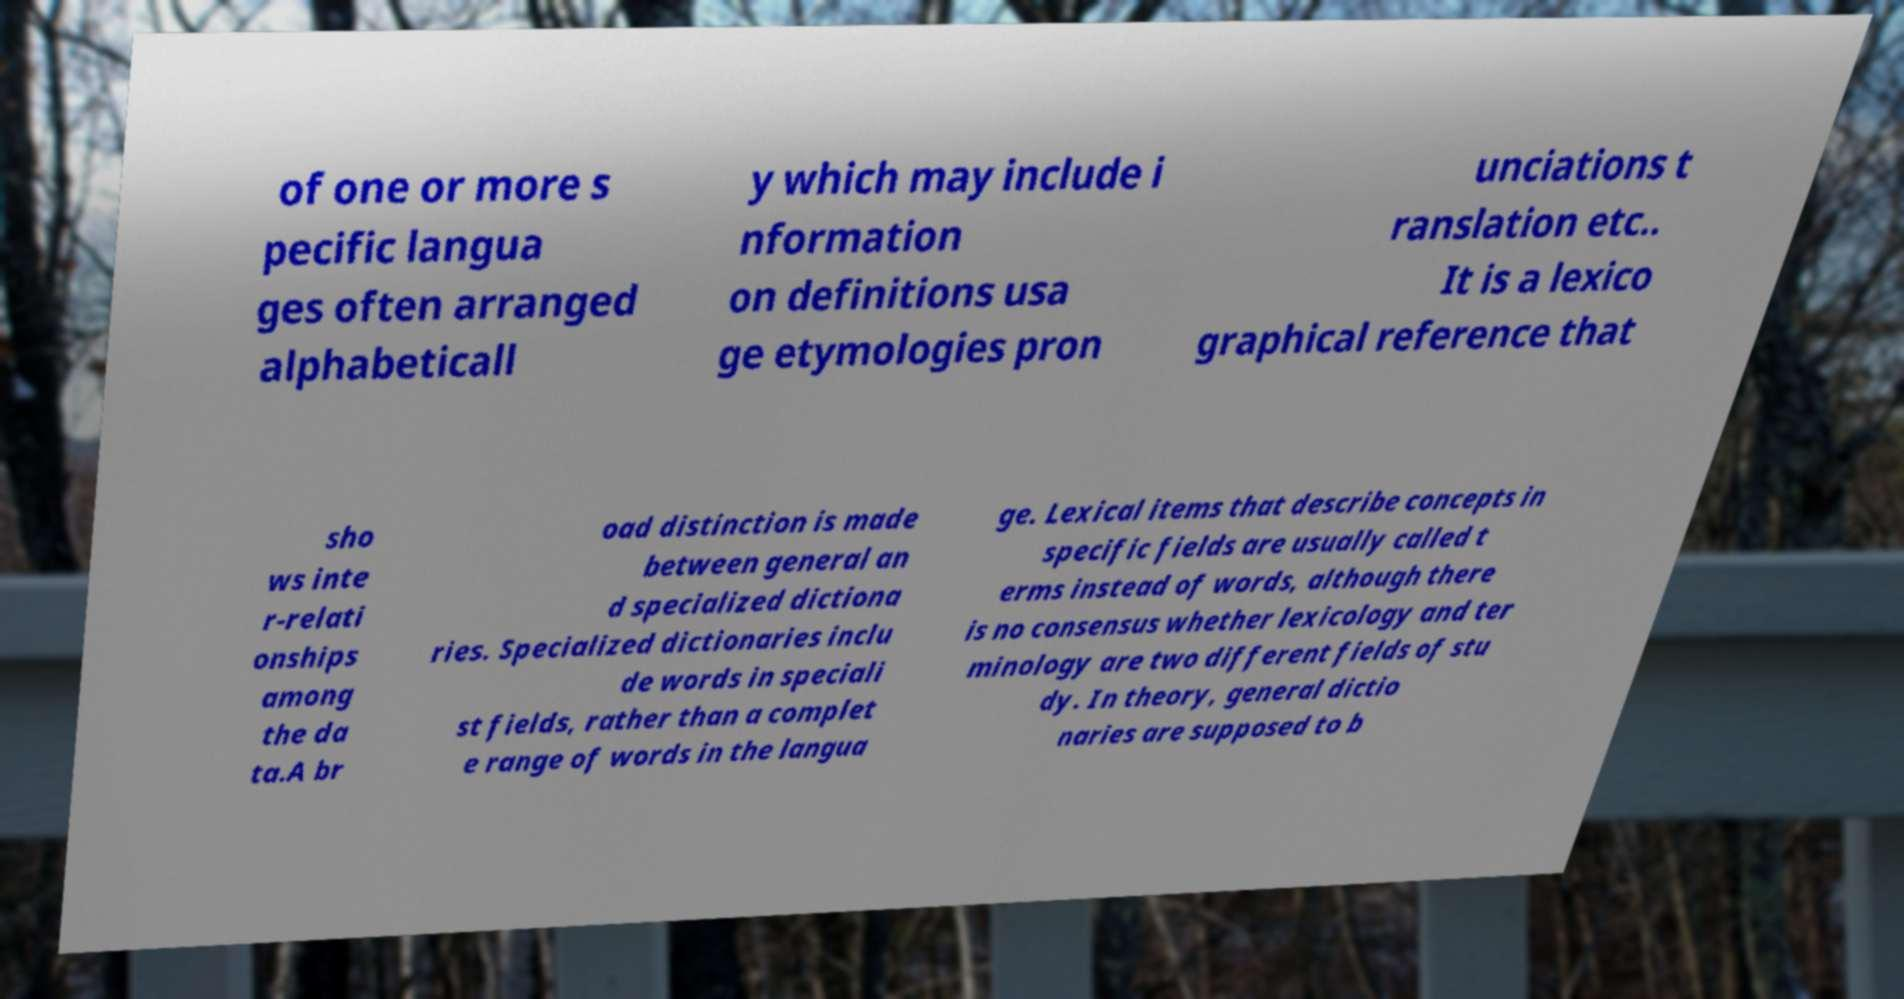Could you assist in decoding the text presented in this image and type it out clearly? of one or more s pecific langua ges often arranged alphabeticall y which may include i nformation on definitions usa ge etymologies pron unciations t ranslation etc.. It is a lexico graphical reference that sho ws inte r-relati onships among the da ta.A br oad distinction is made between general an d specialized dictiona ries. Specialized dictionaries inclu de words in speciali st fields, rather than a complet e range of words in the langua ge. Lexical items that describe concepts in specific fields are usually called t erms instead of words, although there is no consensus whether lexicology and ter minology are two different fields of stu dy. In theory, general dictio naries are supposed to b 